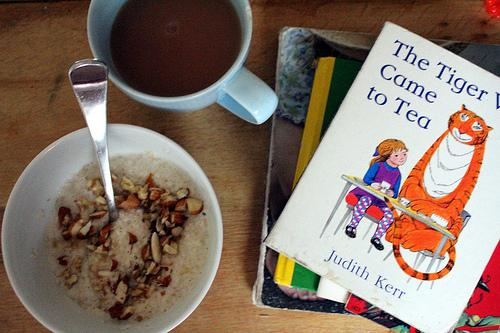Question: what is sitting next to the girl?
Choices:
A. Lion.
B. Tiger.
C. Camel.
D. Zebra.
Answer with the letter. Answer: B Question: where is the coffee?
Choices:
A. Cup.
B. Mug.
C. Coffee maker.
D. Glass.
Answer with the letter. Answer: B Question: who wrote the book?
Choices:
A. Julius Vern.
B. James Patterson.
C. Judith Kerr.
D. John Grisham.
Answer with the letter. Answer: C Question: how many cups of coffee are shown?
Choices:
A. 2.
B. 3.
C. 1.
D. 4.
Answer with the letter. Answer: C Question: what color is the book on top's background?
Choices:
A. White.
B. Black.
C. Blue.
D. Red.
Answer with the letter. Answer: A 